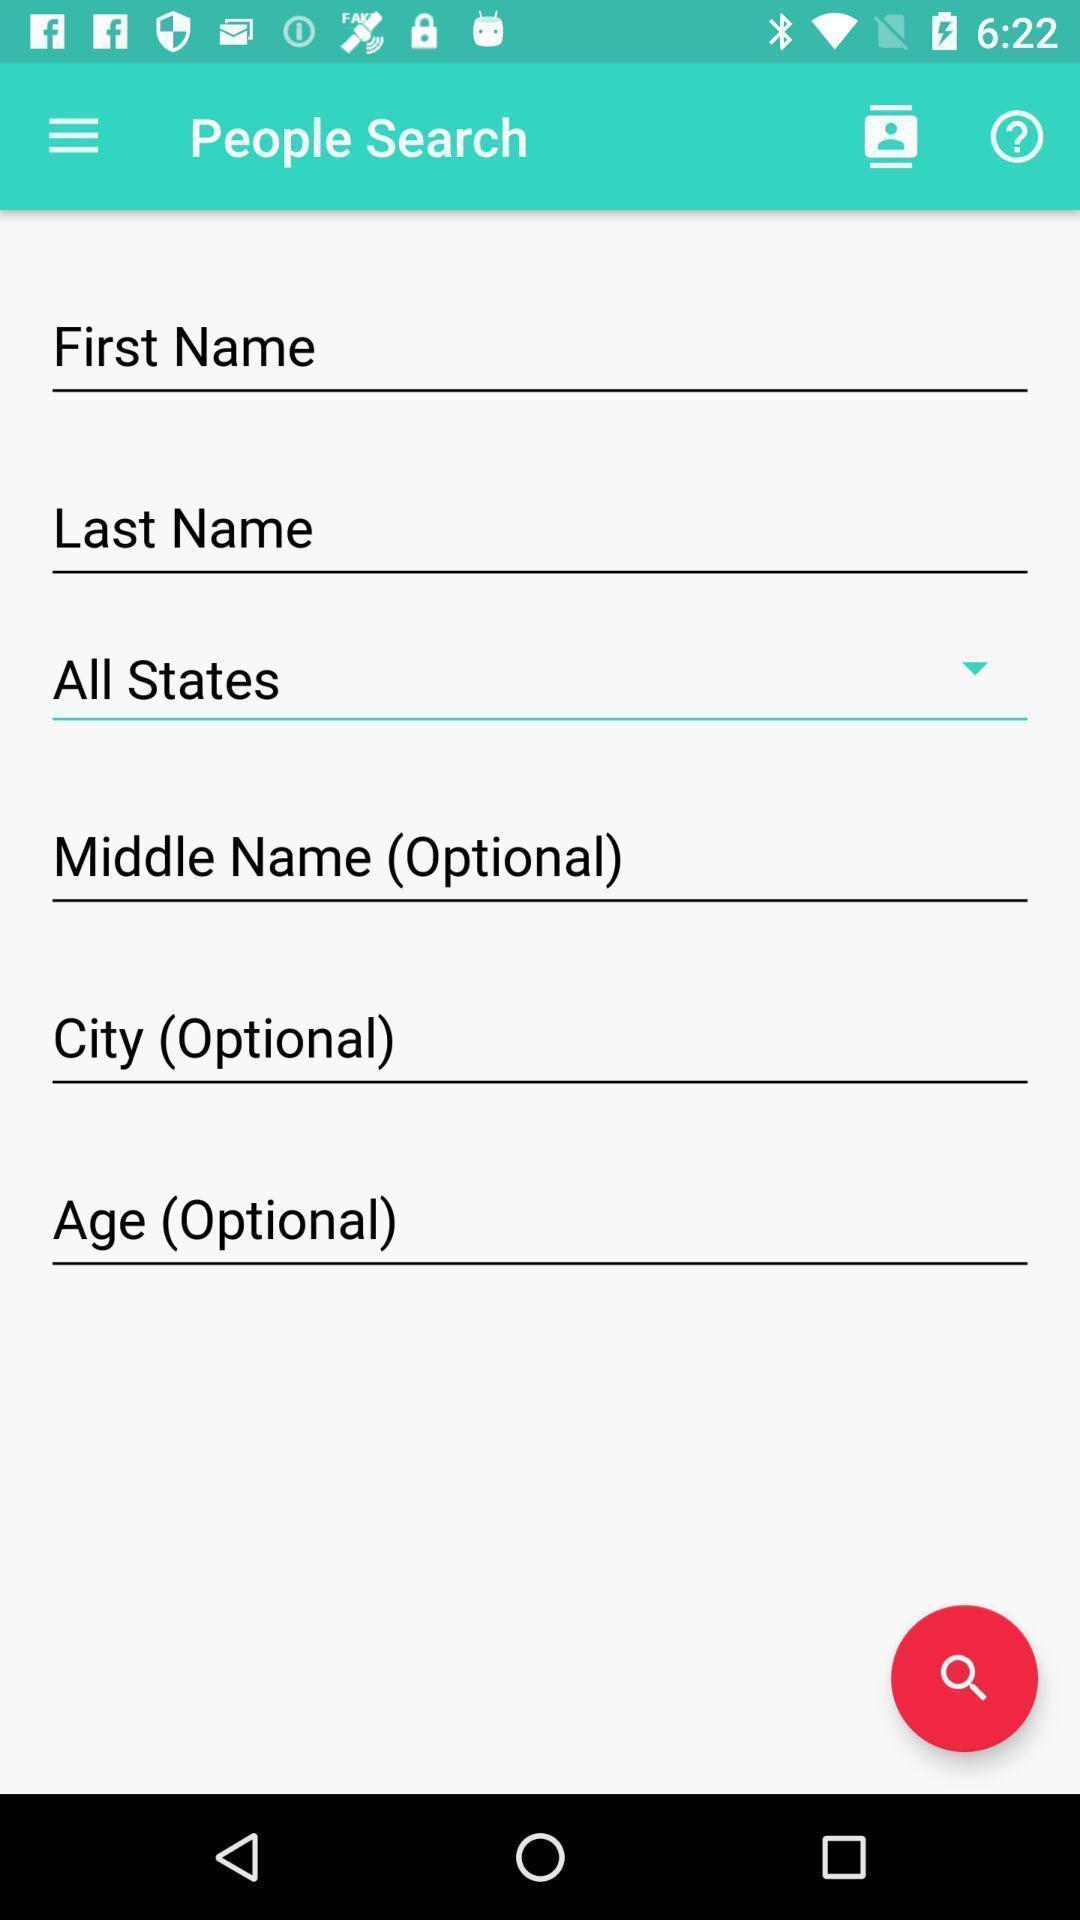Describe the content in this image. Screen displaying page about people search. 